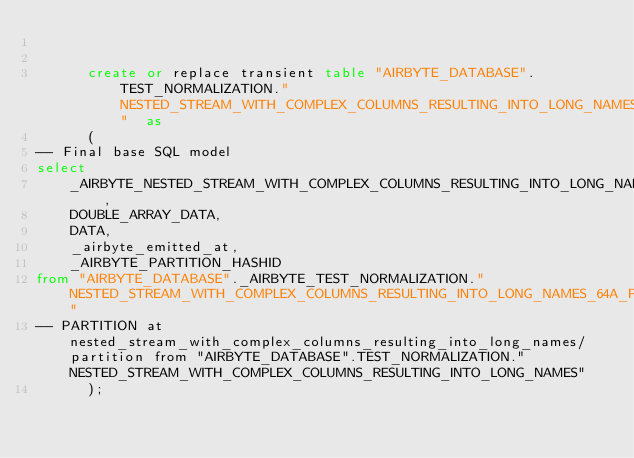Convert code to text. <code><loc_0><loc_0><loc_500><loc_500><_SQL_>

      create or replace transient table "AIRBYTE_DATABASE".TEST_NORMALIZATION."NESTED_STREAM_WITH_COMPLEX_COLUMNS_RESULTING_INTO_LONG_NAMES_64A_PARTITION"  as
      (
-- Final base SQL model
select
    _AIRBYTE_NESTED_STREAM_WITH_COMPLEX_COLUMNS_RESULTING_INTO_LONG_NAMES_HASHID,
    DOUBLE_ARRAY_DATA,
    DATA,
    _airbyte_emitted_at,
    _AIRBYTE_PARTITION_HASHID
from "AIRBYTE_DATABASE"._AIRBYTE_TEST_NORMALIZATION."NESTED_STREAM_WITH_COMPLEX_COLUMNS_RESULTING_INTO_LONG_NAMES_64A_PARTITION_AB3"
-- PARTITION at nested_stream_with_complex_columns_resulting_into_long_names/partition from "AIRBYTE_DATABASE".TEST_NORMALIZATION."NESTED_STREAM_WITH_COMPLEX_COLUMNS_RESULTING_INTO_LONG_NAMES"
      );
    </code> 